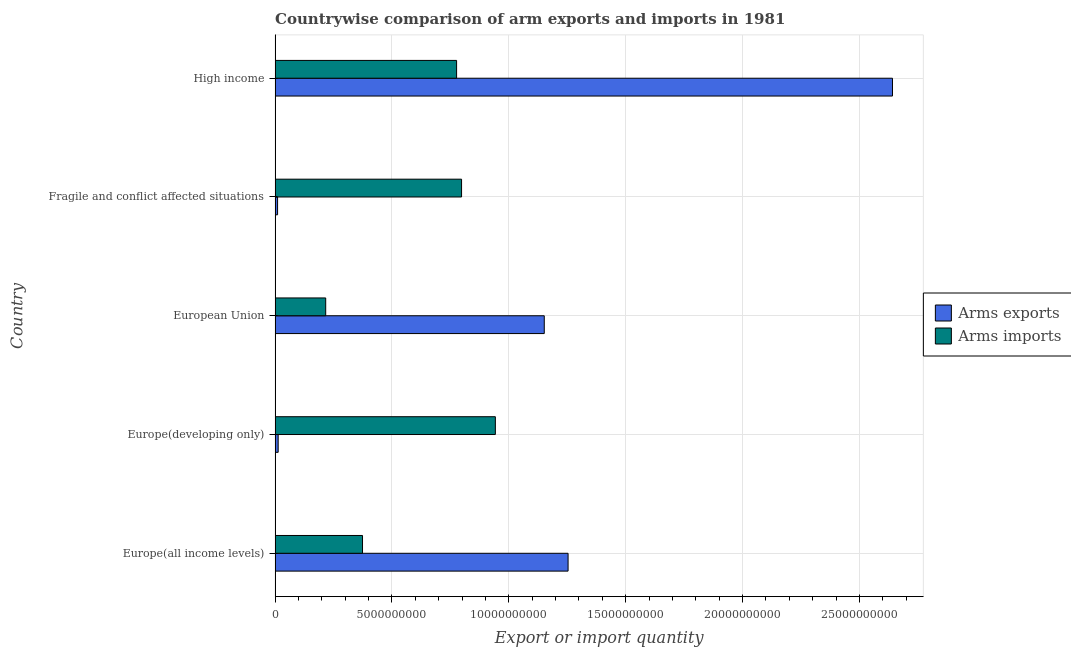How many different coloured bars are there?
Your response must be concise. 2. How many groups of bars are there?
Keep it short and to the point. 5. How many bars are there on the 4th tick from the top?
Ensure brevity in your answer.  2. What is the arms exports in Fragile and conflict affected situations?
Make the answer very short. 1.07e+08. Across all countries, what is the maximum arms imports?
Your answer should be compact. 9.42e+09. Across all countries, what is the minimum arms exports?
Your answer should be compact. 1.07e+08. In which country was the arms imports maximum?
Provide a succinct answer. Europe(developing only). In which country was the arms exports minimum?
Your response must be concise. Fragile and conflict affected situations. What is the total arms exports in the graph?
Provide a short and direct response. 5.07e+1. What is the difference between the arms exports in Europe(developing only) and that in High income?
Keep it short and to the point. -2.63e+1. What is the difference between the arms exports in Europe(all income levels) and the arms imports in European Union?
Provide a succinct answer. 1.04e+1. What is the average arms exports per country?
Make the answer very short. 1.01e+1. What is the difference between the arms exports and arms imports in High income?
Keep it short and to the point. 1.86e+1. What is the ratio of the arms exports in Europe(all income levels) to that in High income?
Ensure brevity in your answer.  0.47. What is the difference between the highest and the second highest arms exports?
Your answer should be compact. 1.39e+1. What is the difference between the highest and the lowest arms exports?
Your answer should be very brief. 2.63e+1. What does the 1st bar from the top in High income represents?
Make the answer very short. Arms imports. What does the 2nd bar from the bottom in Fragile and conflict affected situations represents?
Your answer should be compact. Arms imports. Are the values on the major ticks of X-axis written in scientific E-notation?
Keep it short and to the point. No. Does the graph contain any zero values?
Offer a very short reply. No. How many legend labels are there?
Provide a short and direct response. 2. What is the title of the graph?
Give a very brief answer. Countrywise comparison of arm exports and imports in 1981. What is the label or title of the X-axis?
Keep it short and to the point. Export or import quantity. What is the label or title of the Y-axis?
Provide a short and direct response. Country. What is the Export or import quantity of Arms exports in Europe(all income levels)?
Your answer should be compact. 1.25e+1. What is the Export or import quantity in Arms imports in Europe(all income levels)?
Make the answer very short. 3.74e+09. What is the Export or import quantity in Arms exports in Europe(developing only)?
Keep it short and to the point. 1.32e+08. What is the Export or import quantity of Arms imports in Europe(developing only)?
Your answer should be very brief. 9.42e+09. What is the Export or import quantity in Arms exports in European Union?
Make the answer very short. 1.15e+1. What is the Export or import quantity of Arms imports in European Union?
Ensure brevity in your answer.  2.17e+09. What is the Export or import quantity of Arms exports in Fragile and conflict affected situations?
Offer a very short reply. 1.07e+08. What is the Export or import quantity of Arms imports in Fragile and conflict affected situations?
Provide a short and direct response. 7.98e+09. What is the Export or import quantity in Arms exports in High income?
Your response must be concise. 2.64e+1. What is the Export or import quantity in Arms imports in High income?
Keep it short and to the point. 7.77e+09. Across all countries, what is the maximum Export or import quantity in Arms exports?
Offer a terse response. 2.64e+1. Across all countries, what is the maximum Export or import quantity in Arms imports?
Your answer should be very brief. 9.42e+09. Across all countries, what is the minimum Export or import quantity of Arms exports?
Give a very brief answer. 1.07e+08. Across all countries, what is the minimum Export or import quantity in Arms imports?
Offer a terse response. 2.17e+09. What is the total Export or import quantity of Arms exports in the graph?
Your response must be concise. 5.07e+1. What is the total Export or import quantity of Arms imports in the graph?
Offer a very short reply. 3.11e+1. What is the difference between the Export or import quantity of Arms exports in Europe(all income levels) and that in Europe(developing only)?
Your response must be concise. 1.24e+1. What is the difference between the Export or import quantity in Arms imports in Europe(all income levels) and that in Europe(developing only)?
Provide a succinct answer. -5.68e+09. What is the difference between the Export or import quantity in Arms exports in Europe(all income levels) and that in European Union?
Ensure brevity in your answer.  1.02e+09. What is the difference between the Export or import quantity of Arms imports in Europe(all income levels) and that in European Union?
Offer a very short reply. 1.58e+09. What is the difference between the Export or import quantity of Arms exports in Europe(all income levels) and that in Fragile and conflict affected situations?
Your response must be concise. 1.24e+1. What is the difference between the Export or import quantity of Arms imports in Europe(all income levels) and that in Fragile and conflict affected situations?
Your answer should be very brief. -4.24e+09. What is the difference between the Export or import quantity of Arms exports in Europe(all income levels) and that in High income?
Provide a short and direct response. -1.39e+1. What is the difference between the Export or import quantity of Arms imports in Europe(all income levels) and that in High income?
Your answer should be compact. -4.02e+09. What is the difference between the Export or import quantity in Arms exports in Europe(developing only) and that in European Union?
Make the answer very short. -1.14e+1. What is the difference between the Export or import quantity of Arms imports in Europe(developing only) and that in European Union?
Ensure brevity in your answer.  7.26e+09. What is the difference between the Export or import quantity of Arms exports in Europe(developing only) and that in Fragile and conflict affected situations?
Provide a short and direct response. 2.50e+07. What is the difference between the Export or import quantity in Arms imports in Europe(developing only) and that in Fragile and conflict affected situations?
Ensure brevity in your answer.  1.45e+09. What is the difference between the Export or import quantity of Arms exports in Europe(developing only) and that in High income?
Your answer should be very brief. -2.63e+1. What is the difference between the Export or import quantity of Arms imports in Europe(developing only) and that in High income?
Provide a short and direct response. 1.66e+09. What is the difference between the Export or import quantity of Arms exports in European Union and that in Fragile and conflict affected situations?
Offer a terse response. 1.14e+1. What is the difference between the Export or import quantity in Arms imports in European Union and that in Fragile and conflict affected situations?
Ensure brevity in your answer.  -5.81e+09. What is the difference between the Export or import quantity in Arms exports in European Union and that in High income?
Keep it short and to the point. -1.49e+1. What is the difference between the Export or import quantity of Arms imports in European Union and that in High income?
Give a very brief answer. -5.60e+09. What is the difference between the Export or import quantity in Arms exports in Fragile and conflict affected situations and that in High income?
Make the answer very short. -2.63e+1. What is the difference between the Export or import quantity in Arms imports in Fragile and conflict affected situations and that in High income?
Make the answer very short. 2.13e+08. What is the difference between the Export or import quantity in Arms exports in Europe(all income levels) and the Export or import quantity in Arms imports in Europe(developing only)?
Your answer should be compact. 3.11e+09. What is the difference between the Export or import quantity in Arms exports in Europe(all income levels) and the Export or import quantity in Arms imports in European Union?
Ensure brevity in your answer.  1.04e+1. What is the difference between the Export or import quantity of Arms exports in Europe(all income levels) and the Export or import quantity of Arms imports in Fragile and conflict affected situations?
Give a very brief answer. 4.56e+09. What is the difference between the Export or import quantity of Arms exports in Europe(all income levels) and the Export or import quantity of Arms imports in High income?
Offer a terse response. 4.77e+09. What is the difference between the Export or import quantity in Arms exports in Europe(developing only) and the Export or import quantity in Arms imports in European Union?
Ensure brevity in your answer.  -2.03e+09. What is the difference between the Export or import quantity of Arms exports in Europe(developing only) and the Export or import quantity of Arms imports in Fragile and conflict affected situations?
Offer a very short reply. -7.85e+09. What is the difference between the Export or import quantity in Arms exports in Europe(developing only) and the Export or import quantity in Arms imports in High income?
Offer a terse response. -7.63e+09. What is the difference between the Export or import quantity in Arms exports in European Union and the Export or import quantity in Arms imports in Fragile and conflict affected situations?
Ensure brevity in your answer.  3.54e+09. What is the difference between the Export or import quantity in Arms exports in European Union and the Export or import quantity in Arms imports in High income?
Keep it short and to the point. 3.75e+09. What is the difference between the Export or import quantity of Arms exports in Fragile and conflict affected situations and the Export or import quantity of Arms imports in High income?
Provide a succinct answer. -7.66e+09. What is the average Export or import quantity of Arms exports per country?
Your answer should be compact. 1.01e+1. What is the average Export or import quantity of Arms imports per country?
Provide a succinct answer. 6.22e+09. What is the difference between the Export or import quantity of Arms exports and Export or import quantity of Arms imports in Europe(all income levels)?
Provide a succinct answer. 8.80e+09. What is the difference between the Export or import quantity of Arms exports and Export or import quantity of Arms imports in Europe(developing only)?
Offer a very short reply. -9.29e+09. What is the difference between the Export or import quantity in Arms exports and Export or import quantity in Arms imports in European Union?
Keep it short and to the point. 9.35e+09. What is the difference between the Export or import quantity of Arms exports and Export or import quantity of Arms imports in Fragile and conflict affected situations?
Keep it short and to the point. -7.87e+09. What is the difference between the Export or import quantity in Arms exports and Export or import quantity in Arms imports in High income?
Give a very brief answer. 1.86e+1. What is the ratio of the Export or import quantity of Arms exports in Europe(all income levels) to that in Europe(developing only)?
Ensure brevity in your answer.  94.97. What is the ratio of the Export or import quantity of Arms imports in Europe(all income levels) to that in Europe(developing only)?
Your response must be concise. 0.4. What is the ratio of the Export or import quantity in Arms exports in Europe(all income levels) to that in European Union?
Provide a short and direct response. 1.09. What is the ratio of the Export or import quantity in Arms imports in Europe(all income levels) to that in European Union?
Your answer should be very brief. 1.73. What is the ratio of the Export or import quantity in Arms exports in Europe(all income levels) to that in Fragile and conflict affected situations?
Your answer should be very brief. 117.16. What is the ratio of the Export or import quantity of Arms imports in Europe(all income levels) to that in Fragile and conflict affected situations?
Your answer should be very brief. 0.47. What is the ratio of the Export or import quantity in Arms exports in Europe(all income levels) to that in High income?
Offer a very short reply. 0.47. What is the ratio of the Export or import quantity in Arms imports in Europe(all income levels) to that in High income?
Provide a short and direct response. 0.48. What is the ratio of the Export or import quantity of Arms exports in Europe(developing only) to that in European Union?
Ensure brevity in your answer.  0.01. What is the ratio of the Export or import quantity in Arms imports in Europe(developing only) to that in European Union?
Offer a terse response. 4.35. What is the ratio of the Export or import quantity of Arms exports in Europe(developing only) to that in Fragile and conflict affected situations?
Your answer should be very brief. 1.23. What is the ratio of the Export or import quantity of Arms imports in Europe(developing only) to that in Fragile and conflict affected situations?
Keep it short and to the point. 1.18. What is the ratio of the Export or import quantity of Arms exports in Europe(developing only) to that in High income?
Offer a terse response. 0.01. What is the ratio of the Export or import quantity of Arms imports in Europe(developing only) to that in High income?
Offer a very short reply. 1.21. What is the ratio of the Export or import quantity in Arms exports in European Union to that in Fragile and conflict affected situations?
Make the answer very short. 107.64. What is the ratio of the Export or import quantity in Arms imports in European Union to that in Fragile and conflict affected situations?
Ensure brevity in your answer.  0.27. What is the ratio of the Export or import quantity in Arms exports in European Union to that in High income?
Give a very brief answer. 0.44. What is the ratio of the Export or import quantity in Arms imports in European Union to that in High income?
Provide a short and direct response. 0.28. What is the ratio of the Export or import quantity in Arms exports in Fragile and conflict affected situations to that in High income?
Make the answer very short. 0. What is the ratio of the Export or import quantity in Arms imports in Fragile and conflict affected situations to that in High income?
Provide a succinct answer. 1.03. What is the difference between the highest and the second highest Export or import quantity in Arms exports?
Give a very brief answer. 1.39e+1. What is the difference between the highest and the second highest Export or import quantity in Arms imports?
Offer a terse response. 1.45e+09. What is the difference between the highest and the lowest Export or import quantity in Arms exports?
Offer a terse response. 2.63e+1. What is the difference between the highest and the lowest Export or import quantity in Arms imports?
Your response must be concise. 7.26e+09. 